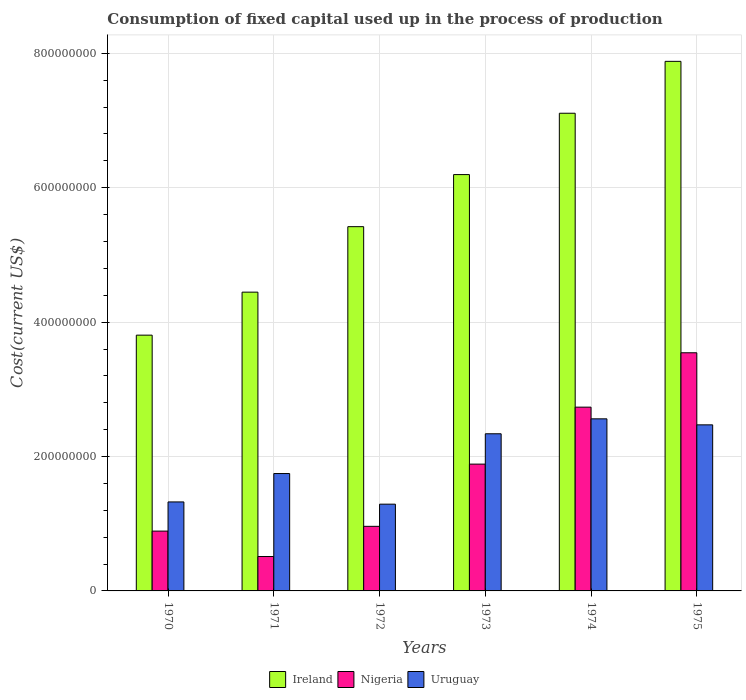In how many cases, is the number of bars for a given year not equal to the number of legend labels?
Your answer should be compact. 0. What is the amount consumed in the process of production in Nigeria in 1973?
Provide a short and direct response. 1.89e+08. Across all years, what is the maximum amount consumed in the process of production in Uruguay?
Provide a succinct answer. 2.56e+08. Across all years, what is the minimum amount consumed in the process of production in Uruguay?
Your answer should be compact. 1.29e+08. In which year was the amount consumed in the process of production in Uruguay maximum?
Provide a succinct answer. 1974. In which year was the amount consumed in the process of production in Uruguay minimum?
Provide a short and direct response. 1972. What is the total amount consumed in the process of production in Ireland in the graph?
Your response must be concise. 3.49e+09. What is the difference between the amount consumed in the process of production in Ireland in 1972 and that in 1975?
Ensure brevity in your answer.  -2.46e+08. What is the difference between the amount consumed in the process of production in Uruguay in 1975 and the amount consumed in the process of production in Ireland in 1970?
Offer a terse response. -1.33e+08. What is the average amount consumed in the process of production in Uruguay per year?
Provide a succinct answer. 1.96e+08. In the year 1971, what is the difference between the amount consumed in the process of production in Nigeria and amount consumed in the process of production in Ireland?
Your answer should be compact. -3.93e+08. What is the ratio of the amount consumed in the process of production in Ireland in 1970 to that in 1973?
Keep it short and to the point. 0.61. Is the amount consumed in the process of production in Ireland in 1970 less than that in 1974?
Ensure brevity in your answer.  Yes. What is the difference between the highest and the second highest amount consumed in the process of production in Ireland?
Your answer should be compact. 7.72e+07. What is the difference between the highest and the lowest amount consumed in the process of production in Uruguay?
Your answer should be compact. 1.27e+08. Is the sum of the amount consumed in the process of production in Uruguay in 1973 and 1974 greater than the maximum amount consumed in the process of production in Ireland across all years?
Offer a very short reply. No. What does the 3rd bar from the left in 1973 represents?
Make the answer very short. Uruguay. What does the 2nd bar from the right in 1974 represents?
Your response must be concise. Nigeria. How many bars are there?
Your answer should be very brief. 18. How many years are there in the graph?
Offer a very short reply. 6. Are the values on the major ticks of Y-axis written in scientific E-notation?
Offer a terse response. No. Where does the legend appear in the graph?
Provide a short and direct response. Bottom center. How many legend labels are there?
Your answer should be very brief. 3. What is the title of the graph?
Ensure brevity in your answer.  Consumption of fixed capital used up in the process of production. What is the label or title of the X-axis?
Provide a short and direct response. Years. What is the label or title of the Y-axis?
Make the answer very short. Cost(current US$). What is the Cost(current US$) of Ireland in 1970?
Keep it short and to the point. 3.81e+08. What is the Cost(current US$) in Nigeria in 1970?
Ensure brevity in your answer.  8.90e+07. What is the Cost(current US$) of Uruguay in 1970?
Offer a very short reply. 1.32e+08. What is the Cost(current US$) in Ireland in 1971?
Provide a succinct answer. 4.45e+08. What is the Cost(current US$) in Nigeria in 1971?
Give a very brief answer. 5.12e+07. What is the Cost(current US$) of Uruguay in 1971?
Give a very brief answer. 1.75e+08. What is the Cost(current US$) of Ireland in 1972?
Give a very brief answer. 5.42e+08. What is the Cost(current US$) in Nigeria in 1972?
Offer a very short reply. 9.61e+07. What is the Cost(current US$) in Uruguay in 1972?
Provide a short and direct response. 1.29e+08. What is the Cost(current US$) of Ireland in 1973?
Offer a very short reply. 6.20e+08. What is the Cost(current US$) of Nigeria in 1973?
Your response must be concise. 1.89e+08. What is the Cost(current US$) in Uruguay in 1973?
Your answer should be compact. 2.34e+08. What is the Cost(current US$) in Ireland in 1974?
Provide a short and direct response. 7.11e+08. What is the Cost(current US$) of Nigeria in 1974?
Keep it short and to the point. 2.73e+08. What is the Cost(current US$) of Uruguay in 1974?
Offer a very short reply. 2.56e+08. What is the Cost(current US$) in Ireland in 1975?
Provide a short and direct response. 7.88e+08. What is the Cost(current US$) of Nigeria in 1975?
Give a very brief answer. 3.54e+08. What is the Cost(current US$) of Uruguay in 1975?
Offer a very short reply. 2.47e+08. Across all years, what is the maximum Cost(current US$) in Ireland?
Your answer should be very brief. 7.88e+08. Across all years, what is the maximum Cost(current US$) in Nigeria?
Provide a succinct answer. 3.54e+08. Across all years, what is the maximum Cost(current US$) of Uruguay?
Offer a very short reply. 2.56e+08. Across all years, what is the minimum Cost(current US$) in Ireland?
Your answer should be very brief. 3.81e+08. Across all years, what is the minimum Cost(current US$) in Nigeria?
Provide a succinct answer. 5.12e+07. Across all years, what is the minimum Cost(current US$) in Uruguay?
Your answer should be very brief. 1.29e+08. What is the total Cost(current US$) in Ireland in the graph?
Your answer should be very brief. 3.49e+09. What is the total Cost(current US$) in Nigeria in the graph?
Your response must be concise. 1.05e+09. What is the total Cost(current US$) in Uruguay in the graph?
Keep it short and to the point. 1.17e+09. What is the difference between the Cost(current US$) of Ireland in 1970 and that in 1971?
Provide a succinct answer. -6.40e+07. What is the difference between the Cost(current US$) of Nigeria in 1970 and that in 1971?
Your answer should be compact. 3.78e+07. What is the difference between the Cost(current US$) of Uruguay in 1970 and that in 1971?
Give a very brief answer. -4.22e+07. What is the difference between the Cost(current US$) in Ireland in 1970 and that in 1972?
Provide a short and direct response. -1.61e+08. What is the difference between the Cost(current US$) of Nigeria in 1970 and that in 1972?
Your response must be concise. -7.11e+06. What is the difference between the Cost(current US$) of Uruguay in 1970 and that in 1972?
Make the answer very short. 3.35e+06. What is the difference between the Cost(current US$) in Ireland in 1970 and that in 1973?
Keep it short and to the point. -2.39e+08. What is the difference between the Cost(current US$) in Nigeria in 1970 and that in 1973?
Ensure brevity in your answer.  -9.97e+07. What is the difference between the Cost(current US$) in Uruguay in 1970 and that in 1973?
Offer a terse response. -1.01e+08. What is the difference between the Cost(current US$) of Ireland in 1970 and that in 1974?
Ensure brevity in your answer.  -3.30e+08. What is the difference between the Cost(current US$) in Nigeria in 1970 and that in 1974?
Make the answer very short. -1.84e+08. What is the difference between the Cost(current US$) of Uruguay in 1970 and that in 1974?
Provide a short and direct response. -1.24e+08. What is the difference between the Cost(current US$) of Ireland in 1970 and that in 1975?
Give a very brief answer. -4.07e+08. What is the difference between the Cost(current US$) of Nigeria in 1970 and that in 1975?
Your answer should be very brief. -2.65e+08. What is the difference between the Cost(current US$) in Uruguay in 1970 and that in 1975?
Offer a terse response. -1.15e+08. What is the difference between the Cost(current US$) of Ireland in 1971 and that in 1972?
Your answer should be very brief. -9.75e+07. What is the difference between the Cost(current US$) in Nigeria in 1971 and that in 1972?
Offer a terse response. -4.49e+07. What is the difference between the Cost(current US$) in Uruguay in 1971 and that in 1972?
Give a very brief answer. 4.56e+07. What is the difference between the Cost(current US$) of Ireland in 1971 and that in 1973?
Offer a very short reply. -1.75e+08. What is the difference between the Cost(current US$) of Nigeria in 1971 and that in 1973?
Provide a short and direct response. -1.38e+08. What is the difference between the Cost(current US$) in Uruguay in 1971 and that in 1973?
Offer a very short reply. -5.92e+07. What is the difference between the Cost(current US$) in Ireland in 1971 and that in 1974?
Offer a very short reply. -2.66e+08. What is the difference between the Cost(current US$) of Nigeria in 1971 and that in 1974?
Ensure brevity in your answer.  -2.22e+08. What is the difference between the Cost(current US$) in Uruguay in 1971 and that in 1974?
Offer a terse response. -8.14e+07. What is the difference between the Cost(current US$) in Ireland in 1971 and that in 1975?
Provide a short and direct response. -3.43e+08. What is the difference between the Cost(current US$) in Nigeria in 1971 and that in 1975?
Keep it short and to the point. -3.03e+08. What is the difference between the Cost(current US$) in Uruguay in 1971 and that in 1975?
Your response must be concise. -7.25e+07. What is the difference between the Cost(current US$) of Ireland in 1972 and that in 1973?
Your response must be concise. -7.75e+07. What is the difference between the Cost(current US$) of Nigeria in 1972 and that in 1973?
Your answer should be compact. -9.26e+07. What is the difference between the Cost(current US$) in Uruguay in 1972 and that in 1973?
Your answer should be very brief. -1.05e+08. What is the difference between the Cost(current US$) in Ireland in 1972 and that in 1974?
Make the answer very short. -1.69e+08. What is the difference between the Cost(current US$) of Nigeria in 1972 and that in 1974?
Offer a terse response. -1.77e+08. What is the difference between the Cost(current US$) of Uruguay in 1972 and that in 1974?
Provide a short and direct response. -1.27e+08. What is the difference between the Cost(current US$) of Ireland in 1972 and that in 1975?
Your answer should be compact. -2.46e+08. What is the difference between the Cost(current US$) in Nigeria in 1972 and that in 1975?
Your response must be concise. -2.58e+08. What is the difference between the Cost(current US$) of Uruguay in 1972 and that in 1975?
Offer a terse response. -1.18e+08. What is the difference between the Cost(current US$) of Ireland in 1973 and that in 1974?
Your answer should be very brief. -9.13e+07. What is the difference between the Cost(current US$) of Nigeria in 1973 and that in 1974?
Your answer should be compact. -8.48e+07. What is the difference between the Cost(current US$) of Uruguay in 1973 and that in 1974?
Offer a terse response. -2.22e+07. What is the difference between the Cost(current US$) in Ireland in 1973 and that in 1975?
Your response must be concise. -1.69e+08. What is the difference between the Cost(current US$) of Nigeria in 1973 and that in 1975?
Offer a terse response. -1.66e+08. What is the difference between the Cost(current US$) in Uruguay in 1973 and that in 1975?
Provide a succinct answer. -1.33e+07. What is the difference between the Cost(current US$) in Ireland in 1974 and that in 1975?
Keep it short and to the point. -7.72e+07. What is the difference between the Cost(current US$) in Nigeria in 1974 and that in 1975?
Provide a short and direct response. -8.09e+07. What is the difference between the Cost(current US$) of Uruguay in 1974 and that in 1975?
Offer a terse response. 8.94e+06. What is the difference between the Cost(current US$) of Ireland in 1970 and the Cost(current US$) of Nigeria in 1971?
Make the answer very short. 3.29e+08. What is the difference between the Cost(current US$) of Ireland in 1970 and the Cost(current US$) of Uruguay in 1971?
Your response must be concise. 2.06e+08. What is the difference between the Cost(current US$) in Nigeria in 1970 and the Cost(current US$) in Uruguay in 1971?
Keep it short and to the point. -8.57e+07. What is the difference between the Cost(current US$) of Ireland in 1970 and the Cost(current US$) of Nigeria in 1972?
Your answer should be very brief. 2.85e+08. What is the difference between the Cost(current US$) of Ireland in 1970 and the Cost(current US$) of Uruguay in 1972?
Make the answer very short. 2.52e+08. What is the difference between the Cost(current US$) in Nigeria in 1970 and the Cost(current US$) in Uruguay in 1972?
Ensure brevity in your answer.  -4.01e+07. What is the difference between the Cost(current US$) of Ireland in 1970 and the Cost(current US$) of Nigeria in 1973?
Give a very brief answer. 1.92e+08. What is the difference between the Cost(current US$) of Ireland in 1970 and the Cost(current US$) of Uruguay in 1973?
Your response must be concise. 1.47e+08. What is the difference between the Cost(current US$) of Nigeria in 1970 and the Cost(current US$) of Uruguay in 1973?
Offer a terse response. -1.45e+08. What is the difference between the Cost(current US$) in Ireland in 1970 and the Cost(current US$) in Nigeria in 1974?
Your answer should be compact. 1.07e+08. What is the difference between the Cost(current US$) in Ireland in 1970 and the Cost(current US$) in Uruguay in 1974?
Give a very brief answer. 1.25e+08. What is the difference between the Cost(current US$) in Nigeria in 1970 and the Cost(current US$) in Uruguay in 1974?
Ensure brevity in your answer.  -1.67e+08. What is the difference between the Cost(current US$) of Ireland in 1970 and the Cost(current US$) of Nigeria in 1975?
Ensure brevity in your answer.  2.62e+07. What is the difference between the Cost(current US$) of Ireland in 1970 and the Cost(current US$) of Uruguay in 1975?
Make the answer very short. 1.33e+08. What is the difference between the Cost(current US$) of Nigeria in 1970 and the Cost(current US$) of Uruguay in 1975?
Your answer should be compact. -1.58e+08. What is the difference between the Cost(current US$) of Ireland in 1971 and the Cost(current US$) of Nigeria in 1972?
Keep it short and to the point. 3.48e+08. What is the difference between the Cost(current US$) in Ireland in 1971 and the Cost(current US$) in Uruguay in 1972?
Your answer should be compact. 3.16e+08. What is the difference between the Cost(current US$) of Nigeria in 1971 and the Cost(current US$) of Uruguay in 1972?
Make the answer very short. -7.79e+07. What is the difference between the Cost(current US$) of Ireland in 1971 and the Cost(current US$) of Nigeria in 1973?
Offer a very short reply. 2.56e+08. What is the difference between the Cost(current US$) in Ireland in 1971 and the Cost(current US$) in Uruguay in 1973?
Ensure brevity in your answer.  2.11e+08. What is the difference between the Cost(current US$) in Nigeria in 1971 and the Cost(current US$) in Uruguay in 1973?
Give a very brief answer. -1.83e+08. What is the difference between the Cost(current US$) of Ireland in 1971 and the Cost(current US$) of Nigeria in 1974?
Provide a succinct answer. 1.71e+08. What is the difference between the Cost(current US$) in Ireland in 1971 and the Cost(current US$) in Uruguay in 1974?
Your answer should be compact. 1.89e+08. What is the difference between the Cost(current US$) in Nigeria in 1971 and the Cost(current US$) in Uruguay in 1974?
Offer a very short reply. -2.05e+08. What is the difference between the Cost(current US$) in Ireland in 1971 and the Cost(current US$) in Nigeria in 1975?
Your answer should be very brief. 9.02e+07. What is the difference between the Cost(current US$) of Ireland in 1971 and the Cost(current US$) of Uruguay in 1975?
Your response must be concise. 1.97e+08. What is the difference between the Cost(current US$) in Nigeria in 1971 and the Cost(current US$) in Uruguay in 1975?
Ensure brevity in your answer.  -1.96e+08. What is the difference between the Cost(current US$) in Ireland in 1972 and the Cost(current US$) in Nigeria in 1973?
Offer a terse response. 3.53e+08. What is the difference between the Cost(current US$) in Ireland in 1972 and the Cost(current US$) in Uruguay in 1973?
Provide a short and direct response. 3.08e+08. What is the difference between the Cost(current US$) in Nigeria in 1972 and the Cost(current US$) in Uruguay in 1973?
Ensure brevity in your answer.  -1.38e+08. What is the difference between the Cost(current US$) in Ireland in 1972 and the Cost(current US$) in Nigeria in 1974?
Give a very brief answer. 2.69e+08. What is the difference between the Cost(current US$) in Ireland in 1972 and the Cost(current US$) in Uruguay in 1974?
Offer a very short reply. 2.86e+08. What is the difference between the Cost(current US$) in Nigeria in 1972 and the Cost(current US$) in Uruguay in 1974?
Your answer should be very brief. -1.60e+08. What is the difference between the Cost(current US$) in Ireland in 1972 and the Cost(current US$) in Nigeria in 1975?
Your answer should be compact. 1.88e+08. What is the difference between the Cost(current US$) in Ireland in 1972 and the Cost(current US$) in Uruguay in 1975?
Ensure brevity in your answer.  2.95e+08. What is the difference between the Cost(current US$) in Nigeria in 1972 and the Cost(current US$) in Uruguay in 1975?
Your response must be concise. -1.51e+08. What is the difference between the Cost(current US$) of Ireland in 1973 and the Cost(current US$) of Nigeria in 1974?
Your answer should be very brief. 3.46e+08. What is the difference between the Cost(current US$) in Ireland in 1973 and the Cost(current US$) in Uruguay in 1974?
Make the answer very short. 3.63e+08. What is the difference between the Cost(current US$) of Nigeria in 1973 and the Cost(current US$) of Uruguay in 1974?
Keep it short and to the point. -6.74e+07. What is the difference between the Cost(current US$) in Ireland in 1973 and the Cost(current US$) in Nigeria in 1975?
Ensure brevity in your answer.  2.65e+08. What is the difference between the Cost(current US$) of Ireland in 1973 and the Cost(current US$) of Uruguay in 1975?
Your answer should be very brief. 3.72e+08. What is the difference between the Cost(current US$) in Nigeria in 1973 and the Cost(current US$) in Uruguay in 1975?
Your answer should be very brief. -5.84e+07. What is the difference between the Cost(current US$) in Ireland in 1974 and the Cost(current US$) in Nigeria in 1975?
Offer a very short reply. 3.56e+08. What is the difference between the Cost(current US$) in Ireland in 1974 and the Cost(current US$) in Uruguay in 1975?
Your answer should be compact. 4.64e+08. What is the difference between the Cost(current US$) of Nigeria in 1974 and the Cost(current US$) of Uruguay in 1975?
Make the answer very short. 2.63e+07. What is the average Cost(current US$) in Ireland per year?
Your answer should be compact. 5.81e+08. What is the average Cost(current US$) in Nigeria per year?
Offer a terse response. 1.75e+08. What is the average Cost(current US$) in Uruguay per year?
Your answer should be compact. 1.96e+08. In the year 1970, what is the difference between the Cost(current US$) of Ireland and Cost(current US$) of Nigeria?
Make the answer very short. 2.92e+08. In the year 1970, what is the difference between the Cost(current US$) in Ireland and Cost(current US$) in Uruguay?
Make the answer very short. 2.48e+08. In the year 1970, what is the difference between the Cost(current US$) in Nigeria and Cost(current US$) in Uruguay?
Make the answer very short. -4.34e+07. In the year 1971, what is the difference between the Cost(current US$) of Ireland and Cost(current US$) of Nigeria?
Ensure brevity in your answer.  3.93e+08. In the year 1971, what is the difference between the Cost(current US$) of Ireland and Cost(current US$) of Uruguay?
Provide a succinct answer. 2.70e+08. In the year 1971, what is the difference between the Cost(current US$) of Nigeria and Cost(current US$) of Uruguay?
Offer a very short reply. -1.24e+08. In the year 1972, what is the difference between the Cost(current US$) in Ireland and Cost(current US$) in Nigeria?
Keep it short and to the point. 4.46e+08. In the year 1972, what is the difference between the Cost(current US$) of Ireland and Cost(current US$) of Uruguay?
Your answer should be compact. 4.13e+08. In the year 1972, what is the difference between the Cost(current US$) in Nigeria and Cost(current US$) in Uruguay?
Your response must be concise. -3.30e+07. In the year 1973, what is the difference between the Cost(current US$) of Ireland and Cost(current US$) of Nigeria?
Your answer should be very brief. 4.31e+08. In the year 1973, what is the difference between the Cost(current US$) of Ireland and Cost(current US$) of Uruguay?
Offer a terse response. 3.86e+08. In the year 1973, what is the difference between the Cost(current US$) of Nigeria and Cost(current US$) of Uruguay?
Your answer should be very brief. -4.51e+07. In the year 1974, what is the difference between the Cost(current US$) in Ireland and Cost(current US$) in Nigeria?
Your answer should be very brief. 4.37e+08. In the year 1974, what is the difference between the Cost(current US$) of Ireland and Cost(current US$) of Uruguay?
Provide a short and direct response. 4.55e+08. In the year 1974, what is the difference between the Cost(current US$) of Nigeria and Cost(current US$) of Uruguay?
Provide a short and direct response. 1.74e+07. In the year 1975, what is the difference between the Cost(current US$) in Ireland and Cost(current US$) in Nigeria?
Provide a succinct answer. 4.34e+08. In the year 1975, what is the difference between the Cost(current US$) in Ireland and Cost(current US$) in Uruguay?
Your answer should be compact. 5.41e+08. In the year 1975, what is the difference between the Cost(current US$) of Nigeria and Cost(current US$) of Uruguay?
Ensure brevity in your answer.  1.07e+08. What is the ratio of the Cost(current US$) in Ireland in 1970 to that in 1971?
Your answer should be very brief. 0.86. What is the ratio of the Cost(current US$) of Nigeria in 1970 to that in 1971?
Offer a terse response. 1.74. What is the ratio of the Cost(current US$) of Uruguay in 1970 to that in 1971?
Your response must be concise. 0.76. What is the ratio of the Cost(current US$) of Ireland in 1970 to that in 1972?
Make the answer very short. 0.7. What is the ratio of the Cost(current US$) of Nigeria in 1970 to that in 1972?
Make the answer very short. 0.93. What is the ratio of the Cost(current US$) of Uruguay in 1970 to that in 1972?
Provide a succinct answer. 1.03. What is the ratio of the Cost(current US$) in Ireland in 1970 to that in 1973?
Make the answer very short. 0.61. What is the ratio of the Cost(current US$) in Nigeria in 1970 to that in 1973?
Keep it short and to the point. 0.47. What is the ratio of the Cost(current US$) in Uruguay in 1970 to that in 1973?
Offer a very short reply. 0.57. What is the ratio of the Cost(current US$) in Ireland in 1970 to that in 1974?
Make the answer very short. 0.54. What is the ratio of the Cost(current US$) of Nigeria in 1970 to that in 1974?
Give a very brief answer. 0.33. What is the ratio of the Cost(current US$) of Uruguay in 1970 to that in 1974?
Make the answer very short. 0.52. What is the ratio of the Cost(current US$) of Ireland in 1970 to that in 1975?
Keep it short and to the point. 0.48. What is the ratio of the Cost(current US$) of Nigeria in 1970 to that in 1975?
Provide a succinct answer. 0.25. What is the ratio of the Cost(current US$) of Uruguay in 1970 to that in 1975?
Make the answer very short. 0.54. What is the ratio of the Cost(current US$) in Ireland in 1971 to that in 1972?
Provide a short and direct response. 0.82. What is the ratio of the Cost(current US$) of Nigeria in 1971 to that in 1972?
Your response must be concise. 0.53. What is the ratio of the Cost(current US$) in Uruguay in 1971 to that in 1972?
Make the answer very short. 1.35. What is the ratio of the Cost(current US$) of Ireland in 1971 to that in 1973?
Your answer should be very brief. 0.72. What is the ratio of the Cost(current US$) of Nigeria in 1971 to that in 1973?
Ensure brevity in your answer.  0.27. What is the ratio of the Cost(current US$) of Uruguay in 1971 to that in 1973?
Give a very brief answer. 0.75. What is the ratio of the Cost(current US$) of Ireland in 1971 to that in 1974?
Make the answer very short. 0.63. What is the ratio of the Cost(current US$) of Nigeria in 1971 to that in 1974?
Give a very brief answer. 0.19. What is the ratio of the Cost(current US$) of Uruguay in 1971 to that in 1974?
Offer a terse response. 0.68. What is the ratio of the Cost(current US$) in Ireland in 1971 to that in 1975?
Your answer should be very brief. 0.56. What is the ratio of the Cost(current US$) of Nigeria in 1971 to that in 1975?
Offer a very short reply. 0.14. What is the ratio of the Cost(current US$) of Uruguay in 1971 to that in 1975?
Make the answer very short. 0.71. What is the ratio of the Cost(current US$) of Ireland in 1972 to that in 1973?
Your answer should be very brief. 0.87. What is the ratio of the Cost(current US$) of Nigeria in 1972 to that in 1973?
Ensure brevity in your answer.  0.51. What is the ratio of the Cost(current US$) in Uruguay in 1972 to that in 1973?
Make the answer very short. 0.55. What is the ratio of the Cost(current US$) in Ireland in 1972 to that in 1974?
Your answer should be very brief. 0.76. What is the ratio of the Cost(current US$) in Nigeria in 1972 to that in 1974?
Your answer should be very brief. 0.35. What is the ratio of the Cost(current US$) of Uruguay in 1972 to that in 1974?
Make the answer very short. 0.5. What is the ratio of the Cost(current US$) of Ireland in 1972 to that in 1975?
Your answer should be very brief. 0.69. What is the ratio of the Cost(current US$) in Nigeria in 1972 to that in 1975?
Make the answer very short. 0.27. What is the ratio of the Cost(current US$) of Uruguay in 1972 to that in 1975?
Provide a short and direct response. 0.52. What is the ratio of the Cost(current US$) of Ireland in 1973 to that in 1974?
Provide a short and direct response. 0.87. What is the ratio of the Cost(current US$) in Nigeria in 1973 to that in 1974?
Offer a terse response. 0.69. What is the ratio of the Cost(current US$) in Uruguay in 1973 to that in 1974?
Provide a succinct answer. 0.91. What is the ratio of the Cost(current US$) of Ireland in 1973 to that in 1975?
Give a very brief answer. 0.79. What is the ratio of the Cost(current US$) in Nigeria in 1973 to that in 1975?
Offer a very short reply. 0.53. What is the ratio of the Cost(current US$) in Uruguay in 1973 to that in 1975?
Your answer should be compact. 0.95. What is the ratio of the Cost(current US$) of Ireland in 1974 to that in 1975?
Your answer should be very brief. 0.9. What is the ratio of the Cost(current US$) in Nigeria in 1974 to that in 1975?
Your answer should be very brief. 0.77. What is the ratio of the Cost(current US$) in Uruguay in 1974 to that in 1975?
Give a very brief answer. 1.04. What is the difference between the highest and the second highest Cost(current US$) of Ireland?
Keep it short and to the point. 7.72e+07. What is the difference between the highest and the second highest Cost(current US$) of Nigeria?
Make the answer very short. 8.09e+07. What is the difference between the highest and the second highest Cost(current US$) of Uruguay?
Offer a very short reply. 8.94e+06. What is the difference between the highest and the lowest Cost(current US$) in Ireland?
Keep it short and to the point. 4.07e+08. What is the difference between the highest and the lowest Cost(current US$) in Nigeria?
Your response must be concise. 3.03e+08. What is the difference between the highest and the lowest Cost(current US$) of Uruguay?
Offer a terse response. 1.27e+08. 